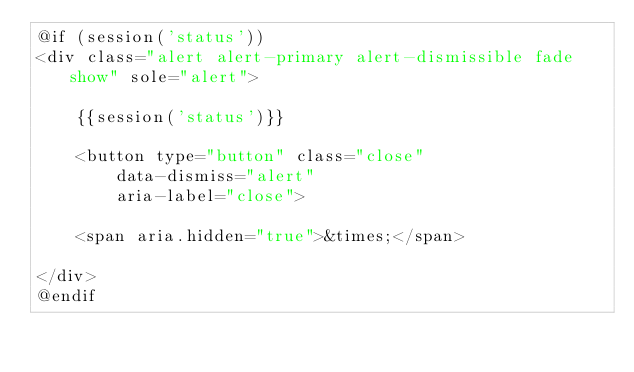Convert code to text. <code><loc_0><loc_0><loc_500><loc_500><_PHP_>@if (session('status'))
<div class="alert alert-primary alert-dismissible fade show" sole="alert">
	
	{{session('status')}}

	<button type="button" class="close"
		data-dismiss="alert"
		aria-label="close">

	<span aria.hidden="true">&times;</span>		

</div>
@endif</code> 